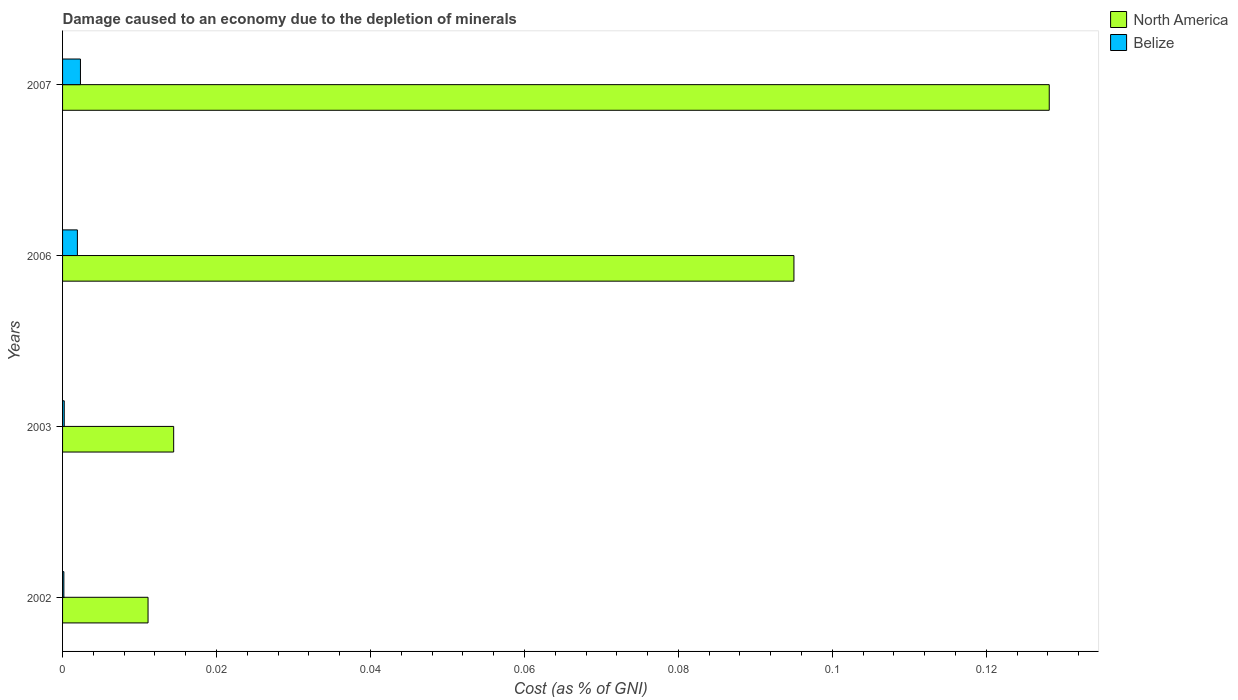Are the number of bars per tick equal to the number of legend labels?
Make the answer very short. Yes. Are the number of bars on each tick of the Y-axis equal?
Give a very brief answer. Yes. How many bars are there on the 3rd tick from the top?
Offer a terse response. 2. How many bars are there on the 2nd tick from the bottom?
Give a very brief answer. 2. In how many cases, is the number of bars for a given year not equal to the number of legend labels?
Give a very brief answer. 0. What is the cost of damage caused due to the depletion of minerals in North America in 2003?
Ensure brevity in your answer.  0.01. Across all years, what is the maximum cost of damage caused due to the depletion of minerals in North America?
Provide a succinct answer. 0.13. Across all years, what is the minimum cost of damage caused due to the depletion of minerals in North America?
Provide a short and direct response. 0.01. In which year was the cost of damage caused due to the depletion of minerals in North America maximum?
Provide a short and direct response. 2007. What is the total cost of damage caused due to the depletion of minerals in North America in the graph?
Provide a succinct answer. 0.25. What is the difference between the cost of damage caused due to the depletion of minerals in North America in 2002 and that in 2007?
Your response must be concise. -0.12. What is the difference between the cost of damage caused due to the depletion of minerals in Belize in 2006 and the cost of damage caused due to the depletion of minerals in North America in 2003?
Provide a short and direct response. -0.01. What is the average cost of damage caused due to the depletion of minerals in Belize per year?
Your answer should be very brief. 0. In the year 2006, what is the difference between the cost of damage caused due to the depletion of minerals in North America and cost of damage caused due to the depletion of minerals in Belize?
Offer a terse response. 0.09. In how many years, is the cost of damage caused due to the depletion of minerals in North America greater than 0.1 %?
Your response must be concise. 1. What is the ratio of the cost of damage caused due to the depletion of minerals in North America in 2002 to that in 2003?
Provide a succinct answer. 0.77. What is the difference between the highest and the second highest cost of damage caused due to the depletion of minerals in Belize?
Ensure brevity in your answer.  0. What is the difference between the highest and the lowest cost of damage caused due to the depletion of minerals in North America?
Offer a very short reply. 0.12. What does the 1st bar from the top in 2003 represents?
Give a very brief answer. Belize. What does the 2nd bar from the bottom in 2002 represents?
Make the answer very short. Belize. How many bars are there?
Ensure brevity in your answer.  8. How many years are there in the graph?
Offer a terse response. 4. What is the difference between two consecutive major ticks on the X-axis?
Your response must be concise. 0.02. Are the values on the major ticks of X-axis written in scientific E-notation?
Ensure brevity in your answer.  No. How many legend labels are there?
Give a very brief answer. 2. How are the legend labels stacked?
Provide a short and direct response. Vertical. What is the title of the graph?
Your answer should be compact. Damage caused to an economy due to the depletion of minerals. What is the label or title of the X-axis?
Give a very brief answer. Cost (as % of GNI). What is the label or title of the Y-axis?
Keep it short and to the point. Years. What is the Cost (as % of GNI) of North America in 2002?
Keep it short and to the point. 0.01. What is the Cost (as % of GNI) of Belize in 2002?
Your answer should be compact. 0. What is the Cost (as % of GNI) of North America in 2003?
Your response must be concise. 0.01. What is the Cost (as % of GNI) of Belize in 2003?
Offer a very short reply. 0. What is the Cost (as % of GNI) of North America in 2006?
Your answer should be very brief. 0.1. What is the Cost (as % of GNI) in Belize in 2006?
Provide a succinct answer. 0. What is the Cost (as % of GNI) in North America in 2007?
Provide a short and direct response. 0.13. What is the Cost (as % of GNI) of Belize in 2007?
Your answer should be compact. 0. Across all years, what is the maximum Cost (as % of GNI) of North America?
Your response must be concise. 0.13. Across all years, what is the maximum Cost (as % of GNI) of Belize?
Ensure brevity in your answer.  0. Across all years, what is the minimum Cost (as % of GNI) of North America?
Provide a short and direct response. 0.01. Across all years, what is the minimum Cost (as % of GNI) of Belize?
Your response must be concise. 0. What is the total Cost (as % of GNI) of North America in the graph?
Offer a terse response. 0.25. What is the total Cost (as % of GNI) in Belize in the graph?
Your response must be concise. 0. What is the difference between the Cost (as % of GNI) in North America in 2002 and that in 2003?
Keep it short and to the point. -0. What is the difference between the Cost (as % of GNI) in Belize in 2002 and that in 2003?
Your response must be concise. -0. What is the difference between the Cost (as % of GNI) of North America in 2002 and that in 2006?
Keep it short and to the point. -0.08. What is the difference between the Cost (as % of GNI) in Belize in 2002 and that in 2006?
Ensure brevity in your answer.  -0. What is the difference between the Cost (as % of GNI) of North America in 2002 and that in 2007?
Your response must be concise. -0.12. What is the difference between the Cost (as % of GNI) in Belize in 2002 and that in 2007?
Keep it short and to the point. -0. What is the difference between the Cost (as % of GNI) of North America in 2003 and that in 2006?
Provide a succinct answer. -0.08. What is the difference between the Cost (as % of GNI) of Belize in 2003 and that in 2006?
Your response must be concise. -0. What is the difference between the Cost (as % of GNI) of North America in 2003 and that in 2007?
Give a very brief answer. -0.11. What is the difference between the Cost (as % of GNI) in Belize in 2003 and that in 2007?
Provide a short and direct response. -0. What is the difference between the Cost (as % of GNI) of North America in 2006 and that in 2007?
Provide a succinct answer. -0.03. What is the difference between the Cost (as % of GNI) of Belize in 2006 and that in 2007?
Your answer should be very brief. -0. What is the difference between the Cost (as % of GNI) of North America in 2002 and the Cost (as % of GNI) of Belize in 2003?
Ensure brevity in your answer.  0.01. What is the difference between the Cost (as % of GNI) of North America in 2002 and the Cost (as % of GNI) of Belize in 2006?
Your answer should be compact. 0.01. What is the difference between the Cost (as % of GNI) of North America in 2002 and the Cost (as % of GNI) of Belize in 2007?
Offer a very short reply. 0.01. What is the difference between the Cost (as % of GNI) in North America in 2003 and the Cost (as % of GNI) in Belize in 2006?
Keep it short and to the point. 0.01. What is the difference between the Cost (as % of GNI) in North America in 2003 and the Cost (as % of GNI) in Belize in 2007?
Offer a very short reply. 0.01. What is the difference between the Cost (as % of GNI) in North America in 2006 and the Cost (as % of GNI) in Belize in 2007?
Provide a succinct answer. 0.09. What is the average Cost (as % of GNI) of North America per year?
Make the answer very short. 0.06. What is the average Cost (as % of GNI) of Belize per year?
Provide a short and direct response. 0. In the year 2002, what is the difference between the Cost (as % of GNI) in North America and Cost (as % of GNI) in Belize?
Make the answer very short. 0.01. In the year 2003, what is the difference between the Cost (as % of GNI) in North America and Cost (as % of GNI) in Belize?
Ensure brevity in your answer.  0.01. In the year 2006, what is the difference between the Cost (as % of GNI) of North America and Cost (as % of GNI) of Belize?
Your response must be concise. 0.09. In the year 2007, what is the difference between the Cost (as % of GNI) in North America and Cost (as % of GNI) in Belize?
Your response must be concise. 0.13. What is the ratio of the Cost (as % of GNI) of North America in 2002 to that in 2003?
Provide a short and direct response. 0.77. What is the ratio of the Cost (as % of GNI) in Belize in 2002 to that in 2003?
Your answer should be compact. 0.79. What is the ratio of the Cost (as % of GNI) in North America in 2002 to that in 2006?
Ensure brevity in your answer.  0.12. What is the ratio of the Cost (as % of GNI) of Belize in 2002 to that in 2006?
Offer a terse response. 0.09. What is the ratio of the Cost (as % of GNI) of North America in 2002 to that in 2007?
Your answer should be very brief. 0.09. What is the ratio of the Cost (as % of GNI) of Belize in 2002 to that in 2007?
Provide a succinct answer. 0.07. What is the ratio of the Cost (as % of GNI) of North America in 2003 to that in 2006?
Ensure brevity in your answer.  0.15. What is the ratio of the Cost (as % of GNI) of Belize in 2003 to that in 2006?
Your response must be concise. 0.11. What is the ratio of the Cost (as % of GNI) in North America in 2003 to that in 2007?
Ensure brevity in your answer.  0.11. What is the ratio of the Cost (as % of GNI) of Belize in 2003 to that in 2007?
Your response must be concise. 0.09. What is the ratio of the Cost (as % of GNI) of North America in 2006 to that in 2007?
Offer a terse response. 0.74. What is the ratio of the Cost (as % of GNI) in Belize in 2006 to that in 2007?
Offer a very short reply. 0.83. What is the difference between the highest and the second highest Cost (as % of GNI) in North America?
Provide a succinct answer. 0.03. What is the difference between the highest and the second highest Cost (as % of GNI) in Belize?
Give a very brief answer. 0. What is the difference between the highest and the lowest Cost (as % of GNI) of North America?
Offer a terse response. 0.12. What is the difference between the highest and the lowest Cost (as % of GNI) of Belize?
Your answer should be compact. 0. 